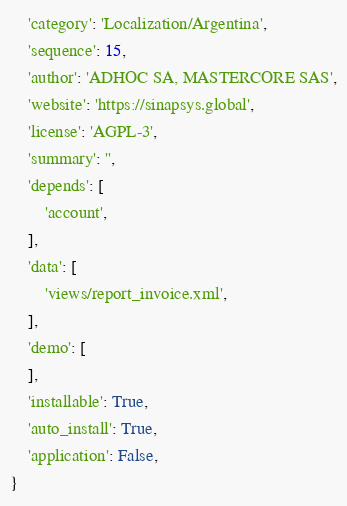<code> <loc_0><loc_0><loc_500><loc_500><_Python_>    'category': 'Localization/Argentina',
    'sequence': 15,
    'author': 'ADHOC SA, MASTERCORE SAS',
    'website': 'https://sinapsys.global',
    'license': 'AGPL-3',
    'summary': '',
    'depends': [
        'account',
    ],
    'data': [
        'views/report_invoice.xml',
    ],
    'demo': [
    ],
    'installable': True,
    'auto_install': True,
    'application': False,
}
</code> 